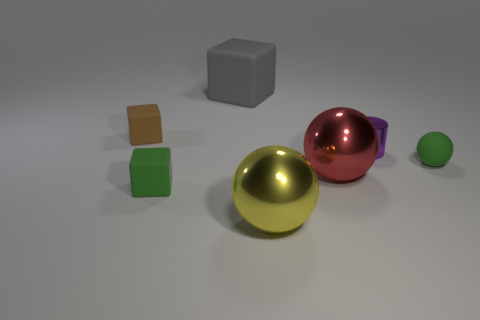There is a rubber ball; is it the same color as the tiny matte object in front of the tiny rubber ball?
Your answer should be very brief. Yes. Is the number of gray rubber blocks that are to the right of the big red object less than the number of large cyan shiny spheres?
Make the answer very short. No. How many other objects are there of the same size as the green cube?
Ensure brevity in your answer.  3. There is a small matte object behind the tiny sphere; is its shape the same as the large gray thing?
Provide a short and direct response. Yes. Is the number of rubber cubes behind the brown cube greater than the number of big green cylinders?
Offer a very short reply. Yes. There is a small thing that is both left of the big yellow shiny ball and behind the red metal thing; what material is it?
Provide a succinct answer. Rubber. Is there anything else that has the same shape as the small shiny thing?
Your response must be concise. No. How many things are both to the left of the purple shiny cylinder and in front of the gray matte object?
Your response must be concise. 4. What is the yellow ball made of?
Provide a short and direct response. Metal. Are there an equal number of large red things that are left of the large gray thing and small yellow matte cylinders?
Your response must be concise. Yes. 